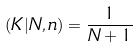<formula> <loc_0><loc_0><loc_500><loc_500>( K | N , n ) = \frac { 1 } { N + 1 }</formula> 